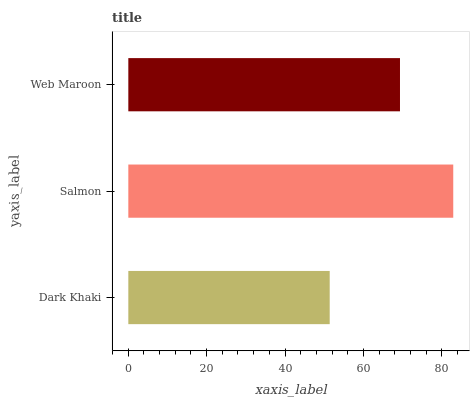Is Dark Khaki the minimum?
Answer yes or no. Yes. Is Salmon the maximum?
Answer yes or no. Yes. Is Web Maroon the minimum?
Answer yes or no. No. Is Web Maroon the maximum?
Answer yes or no. No. Is Salmon greater than Web Maroon?
Answer yes or no. Yes. Is Web Maroon less than Salmon?
Answer yes or no. Yes. Is Web Maroon greater than Salmon?
Answer yes or no. No. Is Salmon less than Web Maroon?
Answer yes or no. No. Is Web Maroon the high median?
Answer yes or no. Yes. Is Web Maroon the low median?
Answer yes or no. Yes. Is Salmon the high median?
Answer yes or no. No. Is Dark Khaki the low median?
Answer yes or no. No. 